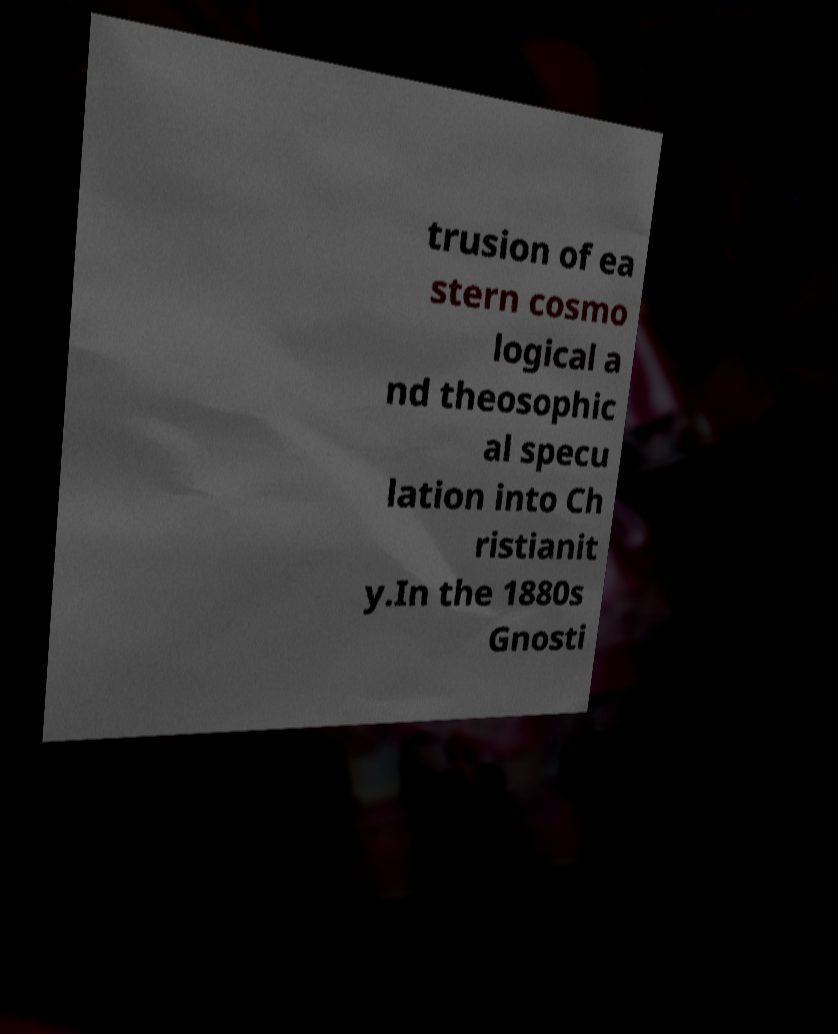There's text embedded in this image that I need extracted. Can you transcribe it verbatim? trusion of ea stern cosmo logical a nd theosophic al specu lation into Ch ristianit y.In the 1880s Gnosti 